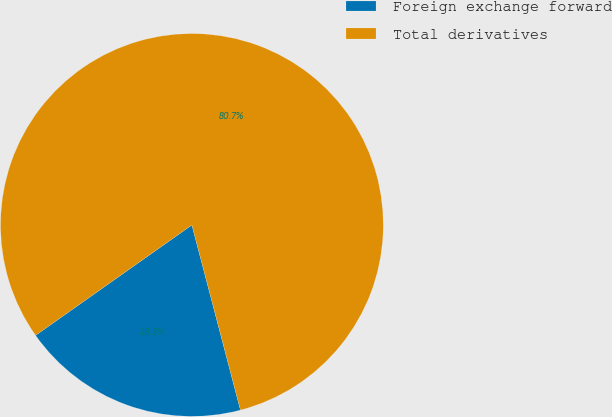Convert chart to OTSL. <chart><loc_0><loc_0><loc_500><loc_500><pie_chart><fcel>Foreign exchange forward<fcel>Total derivatives<nl><fcel>19.3%<fcel>80.7%<nl></chart> 